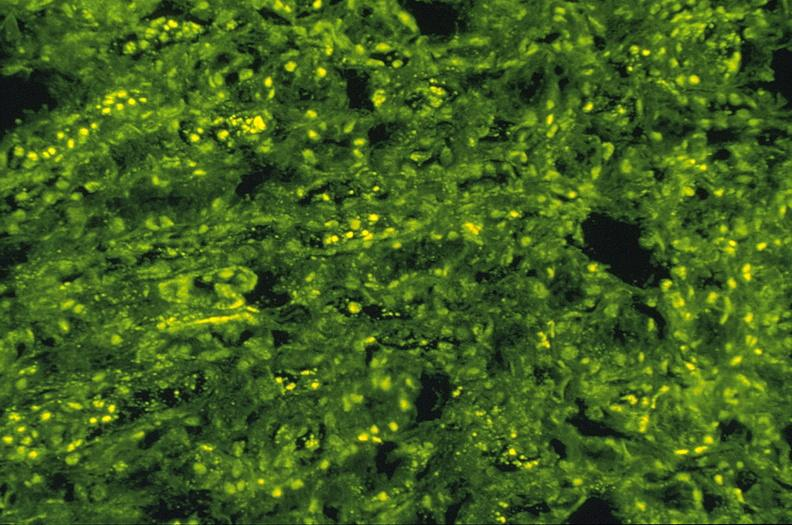s chloramphenicol toxicity present?
Answer the question using a single word or phrase. No 